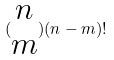Convert formula to latex. <formula><loc_0><loc_0><loc_500><loc_500>( \begin{matrix} n \\ m \end{matrix} ) ( n - m ) !</formula> 